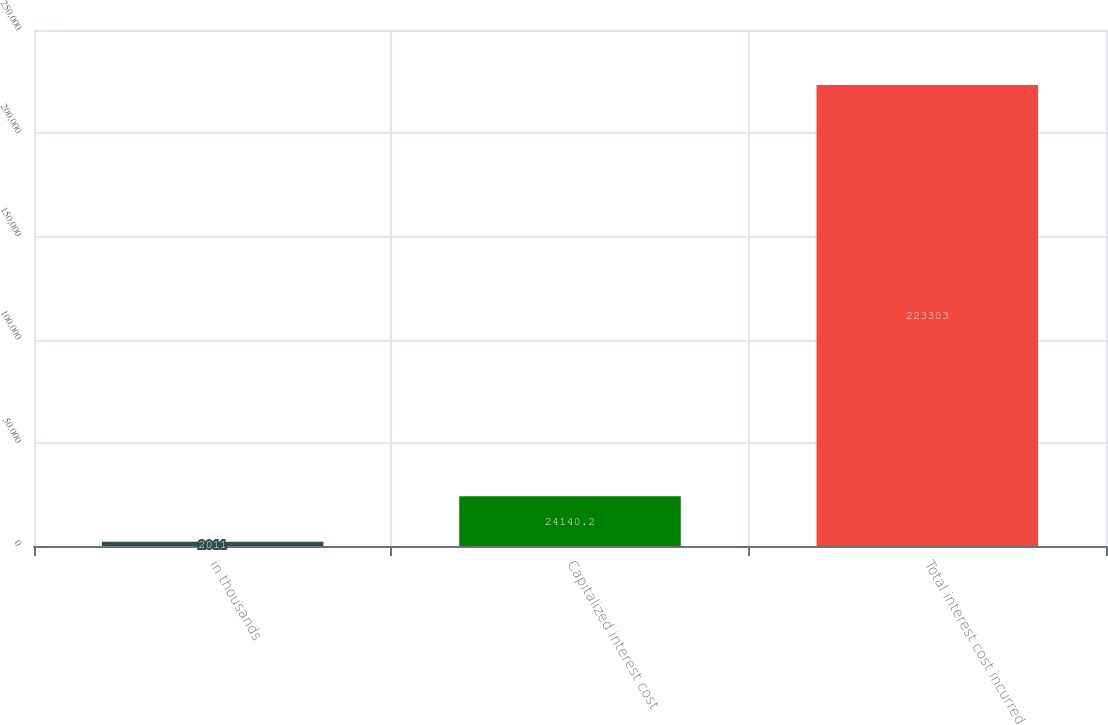Convert chart to OTSL. <chart><loc_0><loc_0><loc_500><loc_500><bar_chart><fcel>in thousands<fcel>Capitalized interest cost<fcel>Total interest cost incurred<nl><fcel>2011<fcel>24140.2<fcel>223303<nl></chart> 